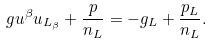<formula> <loc_0><loc_0><loc_500><loc_500>g u ^ { \beta } u _ { L _ { \beta } } + \frac { p } { n _ { L } } = - g _ { L } + \frac { p _ { L } } { n _ { L } } .</formula> 